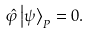<formula> <loc_0><loc_0><loc_500><loc_500>\hat { \varphi } \left | \psi \right \rangle _ { P } = 0 .</formula> 